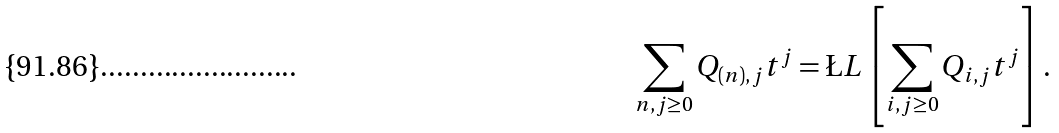Convert formula to latex. <formula><loc_0><loc_0><loc_500><loc_500>\sum _ { n , j \geq 0 } Q _ { ( n ) , j } t ^ { j } = \L L \left [ \sum _ { i , j \geq 0 } Q _ { i , j } t ^ { j } \right ] .</formula> 